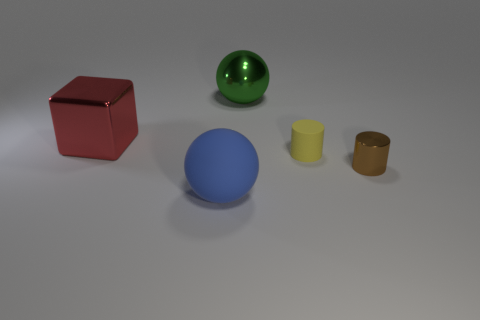Add 1 big yellow spheres. How many objects exist? 6 Subtract all spheres. How many objects are left? 3 Subtract 0 red cylinders. How many objects are left? 5 Subtract all purple cylinders. Subtract all brown cubes. How many cylinders are left? 2 Subtract all big purple metallic cylinders. Subtract all small objects. How many objects are left? 3 Add 5 large blue balls. How many large blue balls are left? 6 Add 1 metallic cylinders. How many metallic cylinders exist? 2 